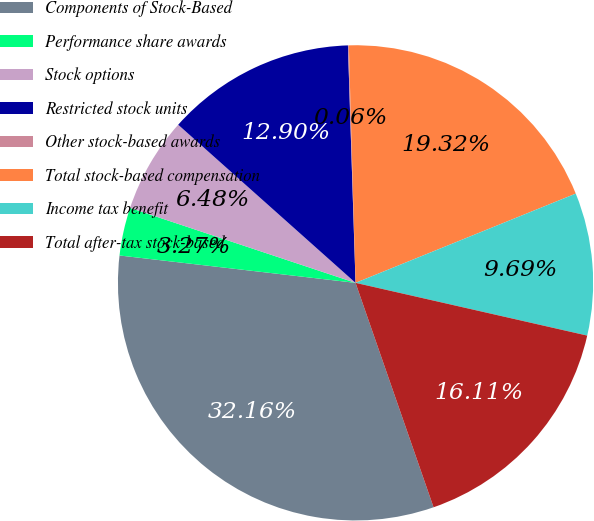<chart> <loc_0><loc_0><loc_500><loc_500><pie_chart><fcel>Components of Stock-Based<fcel>Performance share awards<fcel>Stock options<fcel>Restricted stock units<fcel>Other stock-based awards<fcel>Total stock-based compensation<fcel>Income tax benefit<fcel>Total after-tax stock-based<nl><fcel>32.16%<fcel>3.27%<fcel>6.48%<fcel>12.9%<fcel>0.06%<fcel>19.32%<fcel>9.69%<fcel>16.11%<nl></chart> 